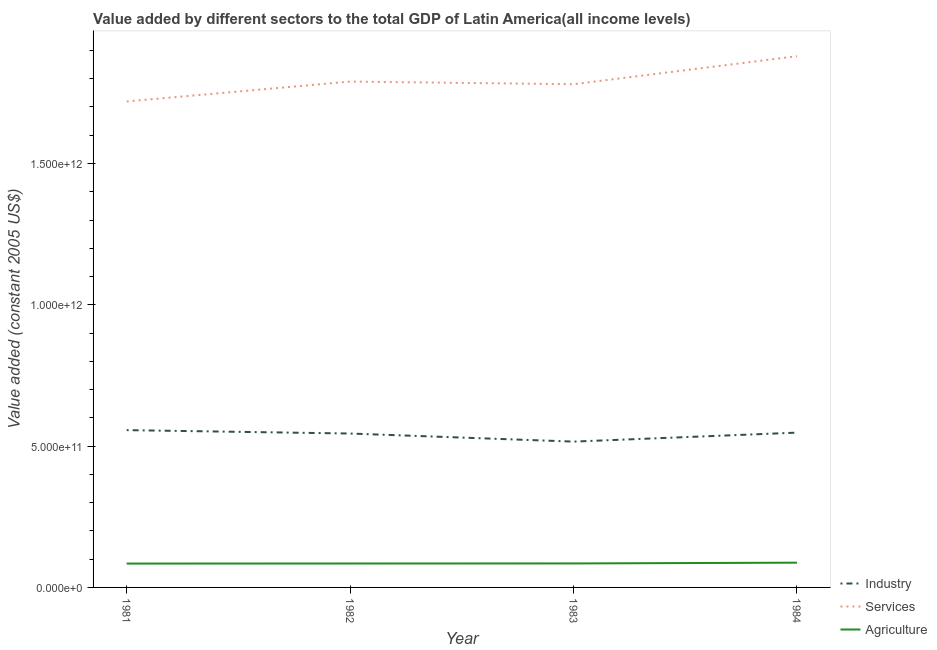Is the number of lines equal to the number of legend labels?
Offer a terse response. Yes. What is the value added by services in 1982?
Give a very brief answer. 1.79e+12. Across all years, what is the maximum value added by agricultural sector?
Offer a very short reply. 8.76e+1. Across all years, what is the minimum value added by services?
Give a very brief answer. 1.72e+12. What is the total value added by services in the graph?
Give a very brief answer. 7.17e+12. What is the difference between the value added by agricultural sector in 1982 and that in 1984?
Give a very brief answer. -2.93e+09. What is the difference between the value added by industrial sector in 1981 and the value added by services in 1982?
Provide a short and direct response. -1.23e+12. What is the average value added by industrial sector per year?
Your answer should be very brief. 5.41e+11. In the year 1981, what is the difference between the value added by industrial sector and value added by services?
Give a very brief answer. -1.16e+12. In how many years, is the value added by services greater than 1500000000000 US$?
Make the answer very short. 4. What is the ratio of the value added by industrial sector in 1982 to that in 1984?
Your response must be concise. 0.99. Is the value added by services in 1981 less than that in 1982?
Keep it short and to the point. Yes. What is the difference between the highest and the second highest value added by services?
Provide a succinct answer. 8.98e+1. What is the difference between the highest and the lowest value added by industrial sector?
Your answer should be very brief. 4.06e+1. In how many years, is the value added by agricultural sector greater than the average value added by agricultural sector taken over all years?
Offer a terse response. 1. Is it the case that in every year, the sum of the value added by industrial sector and value added by services is greater than the value added by agricultural sector?
Provide a succinct answer. Yes. How many lines are there?
Provide a short and direct response. 3. What is the difference between two consecutive major ticks on the Y-axis?
Provide a succinct answer. 5.00e+11. Does the graph contain grids?
Provide a short and direct response. No. What is the title of the graph?
Offer a terse response. Value added by different sectors to the total GDP of Latin America(all income levels). Does "Poland" appear as one of the legend labels in the graph?
Keep it short and to the point. No. What is the label or title of the Y-axis?
Offer a very short reply. Value added (constant 2005 US$). What is the Value added (constant 2005 US$) in Industry in 1981?
Your answer should be compact. 5.57e+11. What is the Value added (constant 2005 US$) of Services in 1981?
Your response must be concise. 1.72e+12. What is the Value added (constant 2005 US$) of Agriculture in 1981?
Offer a terse response. 8.44e+1. What is the Value added (constant 2005 US$) of Industry in 1982?
Your answer should be compact. 5.45e+11. What is the Value added (constant 2005 US$) of Services in 1982?
Make the answer very short. 1.79e+12. What is the Value added (constant 2005 US$) of Agriculture in 1982?
Your answer should be very brief. 8.47e+1. What is the Value added (constant 2005 US$) in Industry in 1983?
Your answer should be compact. 5.16e+11. What is the Value added (constant 2005 US$) of Services in 1983?
Provide a short and direct response. 1.78e+12. What is the Value added (constant 2005 US$) of Agriculture in 1983?
Ensure brevity in your answer.  8.49e+1. What is the Value added (constant 2005 US$) in Industry in 1984?
Your answer should be very brief. 5.48e+11. What is the Value added (constant 2005 US$) in Services in 1984?
Give a very brief answer. 1.88e+12. What is the Value added (constant 2005 US$) in Agriculture in 1984?
Provide a succinct answer. 8.76e+1. Across all years, what is the maximum Value added (constant 2005 US$) of Industry?
Provide a succinct answer. 5.57e+11. Across all years, what is the maximum Value added (constant 2005 US$) in Services?
Ensure brevity in your answer.  1.88e+12. Across all years, what is the maximum Value added (constant 2005 US$) of Agriculture?
Ensure brevity in your answer.  8.76e+1. Across all years, what is the minimum Value added (constant 2005 US$) of Industry?
Your answer should be very brief. 5.16e+11. Across all years, what is the minimum Value added (constant 2005 US$) of Services?
Give a very brief answer. 1.72e+12. Across all years, what is the minimum Value added (constant 2005 US$) in Agriculture?
Provide a succinct answer. 8.44e+1. What is the total Value added (constant 2005 US$) in Industry in the graph?
Provide a short and direct response. 2.16e+12. What is the total Value added (constant 2005 US$) in Services in the graph?
Make the answer very short. 7.17e+12. What is the total Value added (constant 2005 US$) in Agriculture in the graph?
Make the answer very short. 3.42e+11. What is the difference between the Value added (constant 2005 US$) of Industry in 1981 and that in 1982?
Offer a terse response. 1.20e+1. What is the difference between the Value added (constant 2005 US$) in Services in 1981 and that in 1982?
Make the answer very short. -7.04e+1. What is the difference between the Value added (constant 2005 US$) of Agriculture in 1981 and that in 1982?
Provide a short and direct response. -2.37e+08. What is the difference between the Value added (constant 2005 US$) of Industry in 1981 and that in 1983?
Your answer should be very brief. 4.06e+1. What is the difference between the Value added (constant 2005 US$) of Services in 1981 and that in 1983?
Provide a short and direct response. -6.10e+1. What is the difference between the Value added (constant 2005 US$) of Agriculture in 1981 and that in 1983?
Provide a short and direct response. -4.60e+08. What is the difference between the Value added (constant 2005 US$) of Industry in 1981 and that in 1984?
Provide a succinct answer. 8.84e+09. What is the difference between the Value added (constant 2005 US$) in Services in 1981 and that in 1984?
Give a very brief answer. -1.60e+11. What is the difference between the Value added (constant 2005 US$) of Agriculture in 1981 and that in 1984?
Your answer should be compact. -3.16e+09. What is the difference between the Value added (constant 2005 US$) in Industry in 1982 and that in 1983?
Offer a very short reply. 2.86e+1. What is the difference between the Value added (constant 2005 US$) of Services in 1982 and that in 1983?
Offer a terse response. 9.37e+09. What is the difference between the Value added (constant 2005 US$) of Agriculture in 1982 and that in 1983?
Your answer should be compact. -2.23e+08. What is the difference between the Value added (constant 2005 US$) in Industry in 1982 and that in 1984?
Provide a succinct answer. -3.18e+09. What is the difference between the Value added (constant 2005 US$) of Services in 1982 and that in 1984?
Keep it short and to the point. -8.98e+1. What is the difference between the Value added (constant 2005 US$) of Agriculture in 1982 and that in 1984?
Make the answer very short. -2.93e+09. What is the difference between the Value added (constant 2005 US$) of Industry in 1983 and that in 1984?
Your answer should be compact. -3.18e+1. What is the difference between the Value added (constant 2005 US$) in Services in 1983 and that in 1984?
Your answer should be very brief. -9.91e+1. What is the difference between the Value added (constant 2005 US$) of Agriculture in 1983 and that in 1984?
Offer a terse response. -2.70e+09. What is the difference between the Value added (constant 2005 US$) in Industry in 1981 and the Value added (constant 2005 US$) in Services in 1982?
Provide a succinct answer. -1.23e+12. What is the difference between the Value added (constant 2005 US$) in Industry in 1981 and the Value added (constant 2005 US$) in Agriculture in 1982?
Provide a succinct answer. 4.72e+11. What is the difference between the Value added (constant 2005 US$) of Services in 1981 and the Value added (constant 2005 US$) of Agriculture in 1982?
Provide a succinct answer. 1.63e+12. What is the difference between the Value added (constant 2005 US$) in Industry in 1981 and the Value added (constant 2005 US$) in Services in 1983?
Provide a succinct answer. -1.22e+12. What is the difference between the Value added (constant 2005 US$) in Industry in 1981 and the Value added (constant 2005 US$) in Agriculture in 1983?
Your answer should be very brief. 4.72e+11. What is the difference between the Value added (constant 2005 US$) in Services in 1981 and the Value added (constant 2005 US$) in Agriculture in 1983?
Your answer should be very brief. 1.63e+12. What is the difference between the Value added (constant 2005 US$) in Industry in 1981 and the Value added (constant 2005 US$) in Services in 1984?
Keep it short and to the point. -1.32e+12. What is the difference between the Value added (constant 2005 US$) in Industry in 1981 and the Value added (constant 2005 US$) in Agriculture in 1984?
Keep it short and to the point. 4.69e+11. What is the difference between the Value added (constant 2005 US$) in Services in 1981 and the Value added (constant 2005 US$) in Agriculture in 1984?
Provide a short and direct response. 1.63e+12. What is the difference between the Value added (constant 2005 US$) in Industry in 1982 and the Value added (constant 2005 US$) in Services in 1983?
Offer a terse response. -1.24e+12. What is the difference between the Value added (constant 2005 US$) of Industry in 1982 and the Value added (constant 2005 US$) of Agriculture in 1983?
Give a very brief answer. 4.60e+11. What is the difference between the Value added (constant 2005 US$) in Services in 1982 and the Value added (constant 2005 US$) in Agriculture in 1983?
Your answer should be very brief. 1.71e+12. What is the difference between the Value added (constant 2005 US$) in Industry in 1982 and the Value added (constant 2005 US$) in Services in 1984?
Give a very brief answer. -1.34e+12. What is the difference between the Value added (constant 2005 US$) of Industry in 1982 and the Value added (constant 2005 US$) of Agriculture in 1984?
Give a very brief answer. 4.57e+11. What is the difference between the Value added (constant 2005 US$) in Services in 1982 and the Value added (constant 2005 US$) in Agriculture in 1984?
Make the answer very short. 1.70e+12. What is the difference between the Value added (constant 2005 US$) of Industry in 1983 and the Value added (constant 2005 US$) of Services in 1984?
Provide a short and direct response. -1.36e+12. What is the difference between the Value added (constant 2005 US$) of Industry in 1983 and the Value added (constant 2005 US$) of Agriculture in 1984?
Your answer should be compact. 4.28e+11. What is the difference between the Value added (constant 2005 US$) in Services in 1983 and the Value added (constant 2005 US$) in Agriculture in 1984?
Ensure brevity in your answer.  1.69e+12. What is the average Value added (constant 2005 US$) in Industry per year?
Your response must be concise. 5.41e+11. What is the average Value added (constant 2005 US$) in Services per year?
Make the answer very short. 1.79e+12. What is the average Value added (constant 2005 US$) in Agriculture per year?
Offer a terse response. 8.54e+1. In the year 1981, what is the difference between the Value added (constant 2005 US$) of Industry and Value added (constant 2005 US$) of Services?
Provide a short and direct response. -1.16e+12. In the year 1981, what is the difference between the Value added (constant 2005 US$) of Industry and Value added (constant 2005 US$) of Agriculture?
Make the answer very short. 4.72e+11. In the year 1981, what is the difference between the Value added (constant 2005 US$) in Services and Value added (constant 2005 US$) in Agriculture?
Provide a succinct answer. 1.64e+12. In the year 1982, what is the difference between the Value added (constant 2005 US$) of Industry and Value added (constant 2005 US$) of Services?
Provide a succinct answer. -1.25e+12. In the year 1982, what is the difference between the Value added (constant 2005 US$) in Industry and Value added (constant 2005 US$) in Agriculture?
Provide a short and direct response. 4.60e+11. In the year 1982, what is the difference between the Value added (constant 2005 US$) in Services and Value added (constant 2005 US$) in Agriculture?
Give a very brief answer. 1.71e+12. In the year 1983, what is the difference between the Value added (constant 2005 US$) of Industry and Value added (constant 2005 US$) of Services?
Provide a succinct answer. -1.26e+12. In the year 1983, what is the difference between the Value added (constant 2005 US$) in Industry and Value added (constant 2005 US$) in Agriculture?
Your response must be concise. 4.31e+11. In the year 1983, what is the difference between the Value added (constant 2005 US$) in Services and Value added (constant 2005 US$) in Agriculture?
Provide a succinct answer. 1.70e+12. In the year 1984, what is the difference between the Value added (constant 2005 US$) of Industry and Value added (constant 2005 US$) of Services?
Keep it short and to the point. -1.33e+12. In the year 1984, what is the difference between the Value added (constant 2005 US$) in Industry and Value added (constant 2005 US$) in Agriculture?
Keep it short and to the point. 4.60e+11. In the year 1984, what is the difference between the Value added (constant 2005 US$) in Services and Value added (constant 2005 US$) in Agriculture?
Make the answer very short. 1.79e+12. What is the ratio of the Value added (constant 2005 US$) of Industry in 1981 to that in 1982?
Offer a terse response. 1.02. What is the ratio of the Value added (constant 2005 US$) in Services in 1981 to that in 1982?
Your answer should be compact. 0.96. What is the ratio of the Value added (constant 2005 US$) of Industry in 1981 to that in 1983?
Give a very brief answer. 1.08. What is the ratio of the Value added (constant 2005 US$) of Services in 1981 to that in 1983?
Your response must be concise. 0.97. What is the ratio of the Value added (constant 2005 US$) in Agriculture in 1981 to that in 1983?
Your response must be concise. 0.99. What is the ratio of the Value added (constant 2005 US$) of Industry in 1981 to that in 1984?
Provide a short and direct response. 1.02. What is the ratio of the Value added (constant 2005 US$) of Services in 1981 to that in 1984?
Provide a short and direct response. 0.91. What is the ratio of the Value added (constant 2005 US$) of Agriculture in 1981 to that in 1984?
Give a very brief answer. 0.96. What is the ratio of the Value added (constant 2005 US$) in Industry in 1982 to that in 1983?
Your answer should be compact. 1.06. What is the ratio of the Value added (constant 2005 US$) in Services in 1982 to that in 1983?
Your response must be concise. 1.01. What is the ratio of the Value added (constant 2005 US$) of Services in 1982 to that in 1984?
Give a very brief answer. 0.95. What is the ratio of the Value added (constant 2005 US$) of Agriculture in 1982 to that in 1984?
Keep it short and to the point. 0.97. What is the ratio of the Value added (constant 2005 US$) in Industry in 1983 to that in 1984?
Make the answer very short. 0.94. What is the ratio of the Value added (constant 2005 US$) in Services in 1983 to that in 1984?
Make the answer very short. 0.95. What is the ratio of the Value added (constant 2005 US$) of Agriculture in 1983 to that in 1984?
Make the answer very short. 0.97. What is the difference between the highest and the second highest Value added (constant 2005 US$) of Industry?
Make the answer very short. 8.84e+09. What is the difference between the highest and the second highest Value added (constant 2005 US$) in Services?
Ensure brevity in your answer.  8.98e+1. What is the difference between the highest and the second highest Value added (constant 2005 US$) of Agriculture?
Your answer should be very brief. 2.70e+09. What is the difference between the highest and the lowest Value added (constant 2005 US$) of Industry?
Provide a succinct answer. 4.06e+1. What is the difference between the highest and the lowest Value added (constant 2005 US$) in Services?
Offer a very short reply. 1.60e+11. What is the difference between the highest and the lowest Value added (constant 2005 US$) of Agriculture?
Provide a succinct answer. 3.16e+09. 